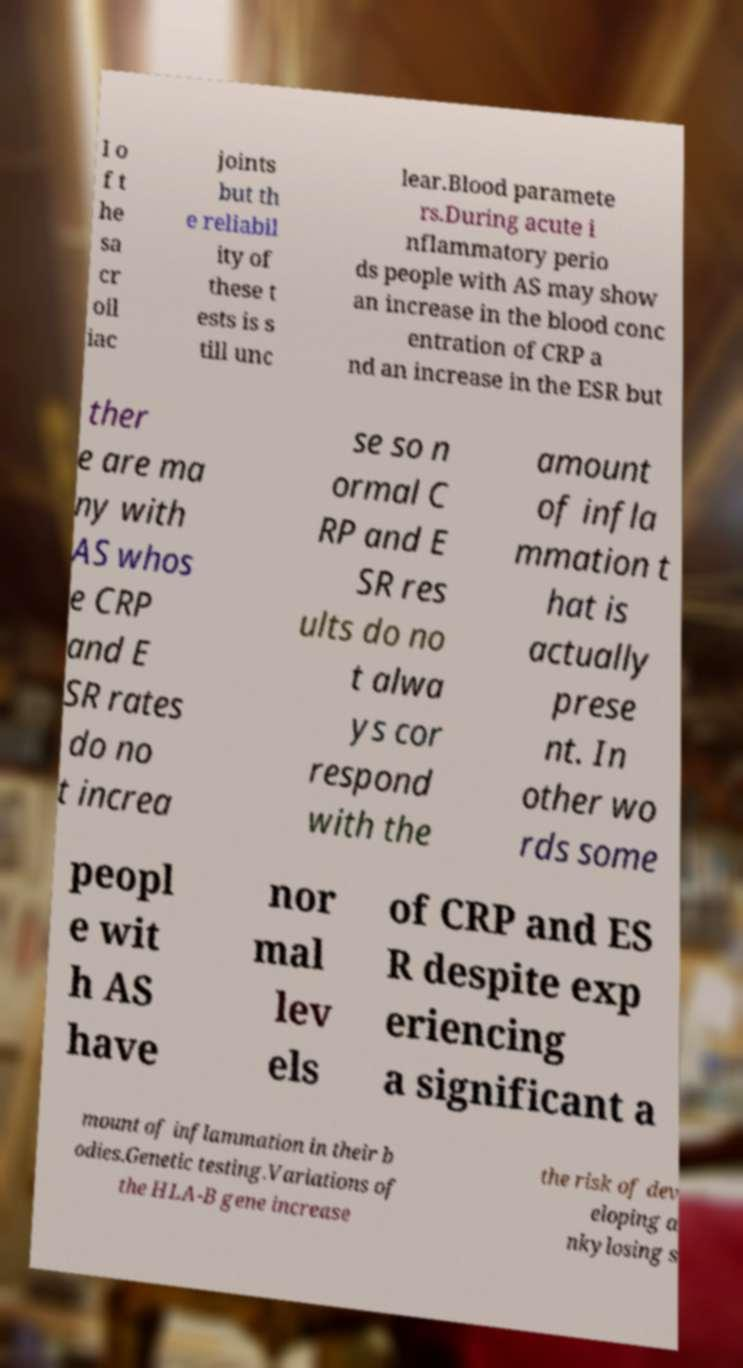Can you accurately transcribe the text from the provided image for me? I o f t he sa cr oil iac joints but th e reliabil ity of these t ests is s till unc lear.Blood paramete rs.During acute i nflammatory perio ds people with AS may show an increase in the blood conc entration of CRP a nd an increase in the ESR but ther e are ma ny with AS whos e CRP and E SR rates do no t increa se so n ormal C RP and E SR res ults do no t alwa ys cor respond with the amount of infla mmation t hat is actually prese nt. In other wo rds some peopl e wit h AS have nor mal lev els of CRP and ES R despite exp eriencing a significant a mount of inflammation in their b odies.Genetic testing.Variations of the HLA-B gene increase the risk of dev eloping a nkylosing s 